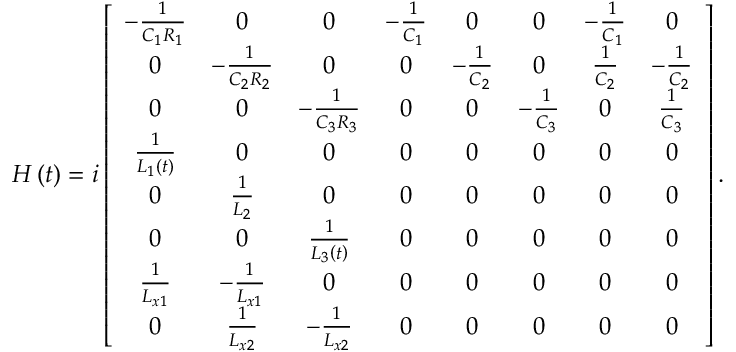<formula> <loc_0><loc_0><loc_500><loc_500>\begin{array} { r } { H \left ( t \right ) = i \left [ \begin{array} { c c c c c c c c } { - \frac { 1 } { C _ { 1 } R _ { 1 } } } & { 0 } & { 0 } & { - \frac { 1 } { C _ { 1 } } } & { 0 } & { 0 } & { - \frac { 1 } { C _ { 1 } } } & { 0 } \\ { 0 } & { - \frac { 1 } { C _ { 2 } R _ { 2 } } } & { 0 } & { 0 } & { - \frac { 1 } { C _ { 2 } } } & { 0 } & { \frac { 1 } { C _ { 2 } } } & { - \frac { 1 } { C _ { 2 } } } \\ { 0 } & { 0 } & { - \frac { 1 } { C _ { 3 } R _ { 3 } } } & { 0 } & { 0 } & { - \frac { 1 } { C _ { 3 } } } & { 0 } & { \frac { 1 } { C _ { 3 } } } \\ { \frac { 1 } { L _ { 1 } \left ( t \right ) } } & { 0 } & { 0 } & { 0 } & { 0 } & { 0 } & { 0 } & { 0 } \\ { 0 } & { \frac { 1 } { L _ { 2 } } } & { 0 } & { 0 } & { 0 } & { 0 } & { 0 } & { 0 } \\ { 0 } & { 0 } & { \frac { 1 } { L _ { 3 } \left ( t \right ) } } & { 0 } & { 0 } & { 0 } & { 0 } & { 0 } \\ { \frac { 1 } { L _ { x 1 } } } & { - \frac { 1 } { L _ { x 1 } } } & { 0 } & { 0 } & { 0 } & { 0 } & { 0 } & { 0 } \\ { 0 } & { \frac { 1 } { L _ { x 2 } } } & { - \frac { 1 } { L _ { x 2 } } } & { 0 } & { 0 } & { 0 } & { 0 } & { 0 } \end{array} \right ] . } \end{array}</formula> 